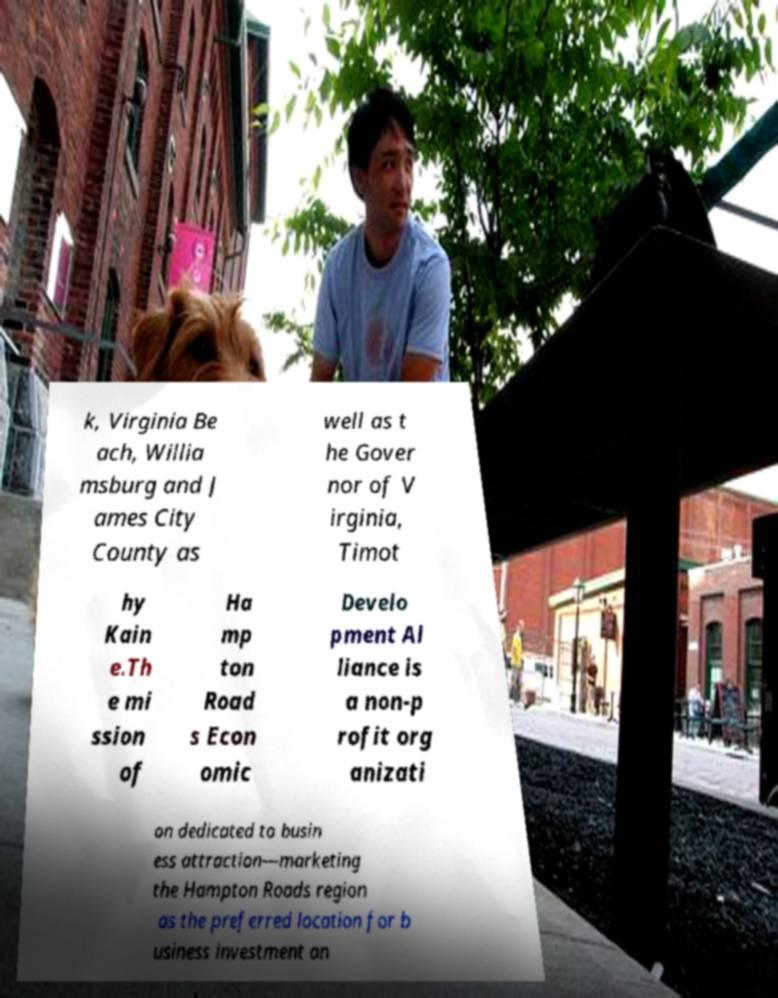Could you assist in decoding the text presented in this image and type it out clearly? k, Virginia Be ach, Willia msburg and J ames City County as well as t he Gover nor of V irginia, Timot hy Kain e.Th e mi ssion of Ha mp ton Road s Econ omic Develo pment Al liance is a non-p rofit org anizati on dedicated to busin ess attraction—marketing the Hampton Roads region as the preferred location for b usiness investment an 